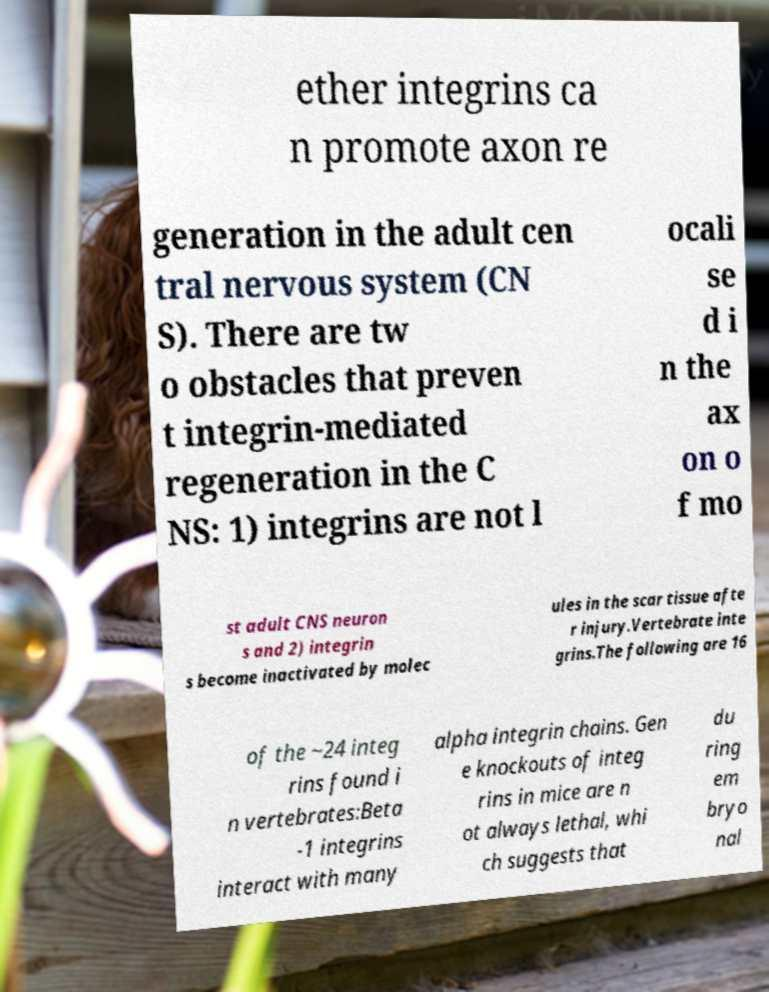What messages or text are displayed in this image? I need them in a readable, typed format. ether integrins ca n promote axon re generation in the adult cen tral nervous system (CN S). There are tw o obstacles that preven t integrin-mediated regeneration in the C NS: 1) integrins are not l ocali se d i n the ax on o f mo st adult CNS neuron s and 2) integrin s become inactivated by molec ules in the scar tissue afte r injury.Vertebrate inte grins.The following are 16 of the ~24 integ rins found i n vertebrates:Beta -1 integrins interact with many alpha integrin chains. Gen e knockouts of integ rins in mice are n ot always lethal, whi ch suggests that du ring em bryo nal 